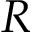Convert formula to latex. <formula><loc_0><loc_0><loc_500><loc_500>R</formula> 